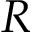Convert formula to latex. <formula><loc_0><loc_0><loc_500><loc_500>R</formula> 